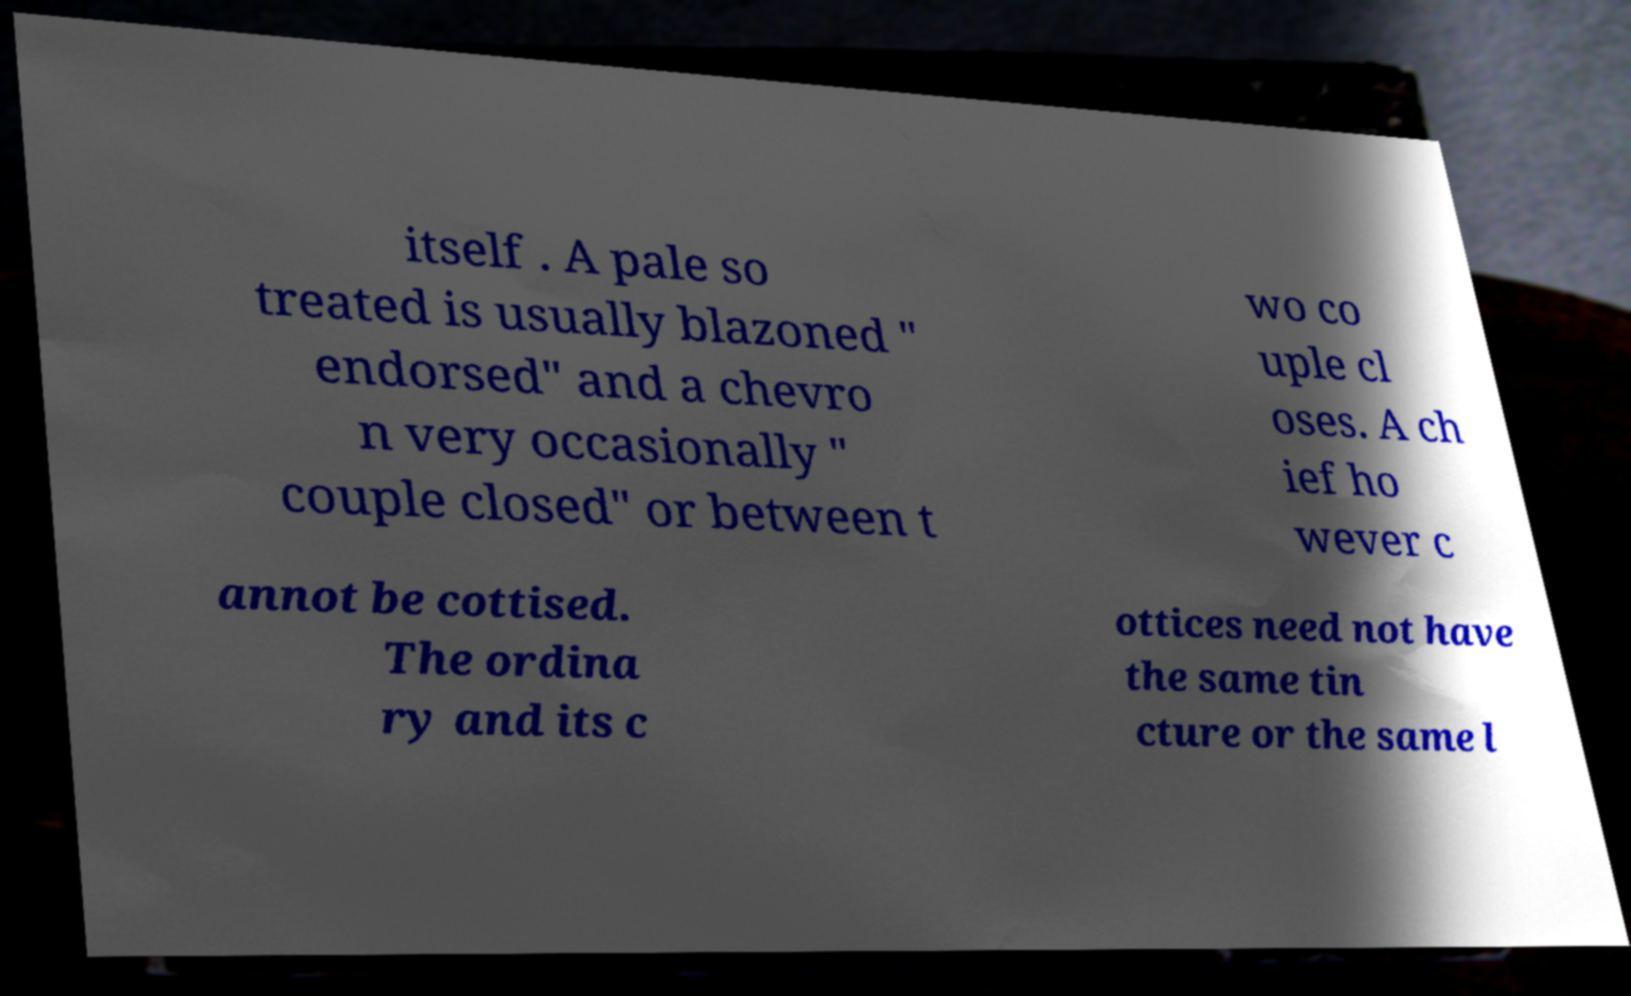Could you extract and type out the text from this image? itself . A pale so treated is usually blazoned " endorsed" and a chevro n very occasionally " couple closed" or between t wo co uple cl oses. A ch ief ho wever c annot be cottised. The ordina ry and its c ottices need not have the same tin cture or the same l 